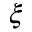<formula> <loc_0><loc_0><loc_500><loc_500>\xi</formula> 